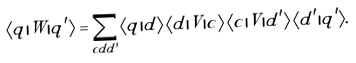Convert formula to latex. <formula><loc_0><loc_0><loc_500><loc_500>\langle q | W | q ^ { \prime } \rangle = \sum _ { c d d ^ { \prime } } \langle q | d \rangle \, \langle d | V | c \rangle \, \langle c | V | d ^ { \prime } \rangle \, \langle d ^ { \prime } | q ^ { \prime } \rangle .</formula> 